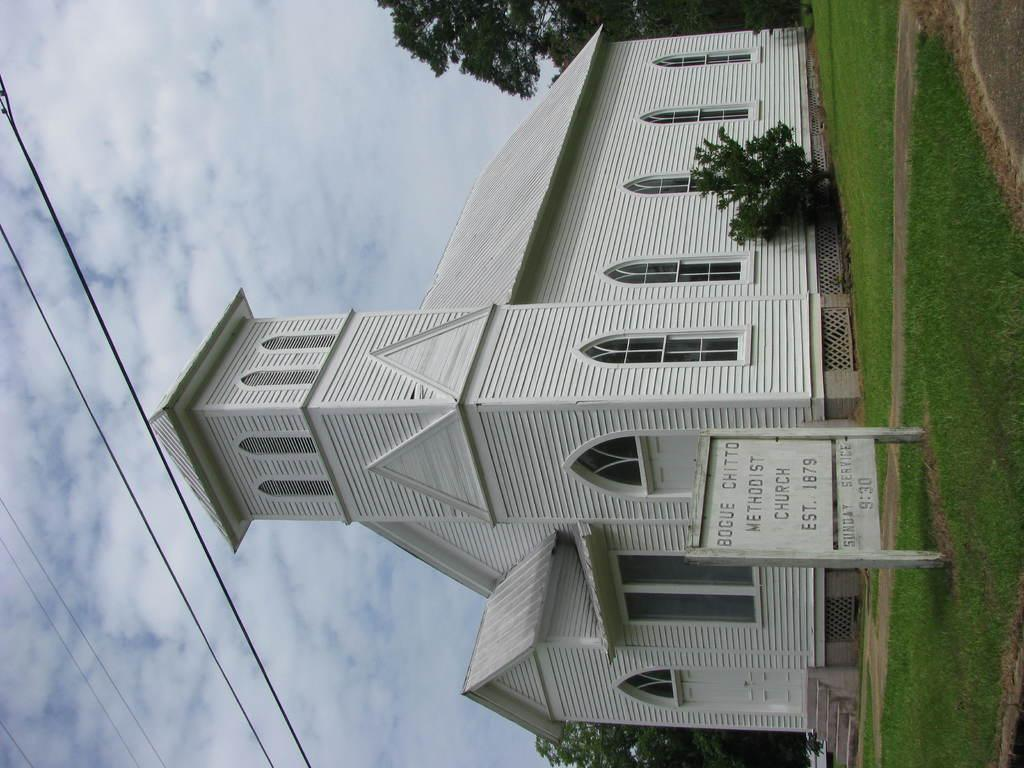<image>
Share a concise interpretation of the image provided. A white wooden church called Bogue Chitto Methodist Church 